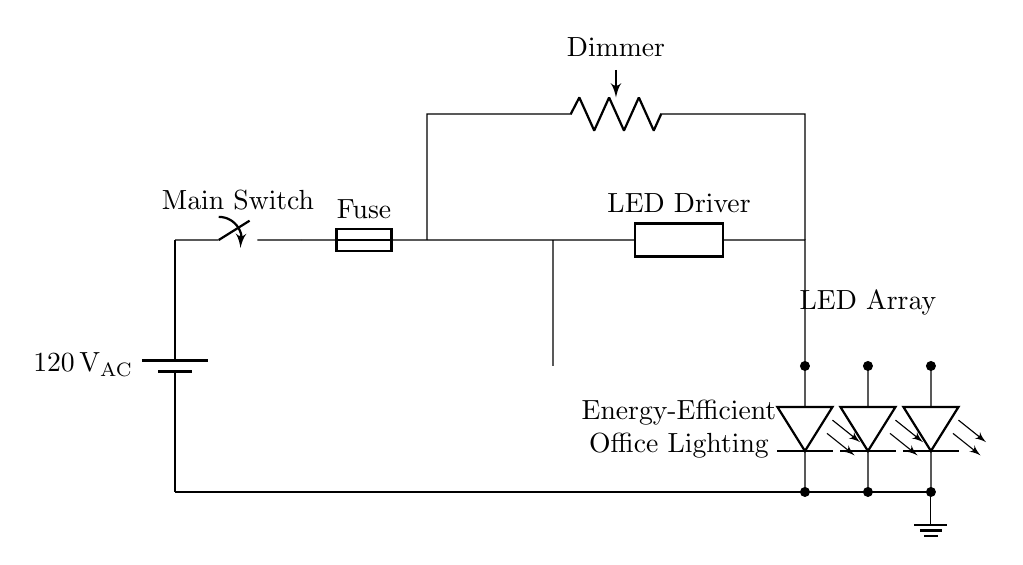What is the main power source used in this circuit? The circuit uses a battery symbol to represent the main power source, which is labeled as 120 volts AC. Therefore, the main power source is AC voltage.
Answer: 120 volts AC What component is used to control the brightness of the LED lights? The dimmer is a potentiometer, which is connected in series with the LED driver, allowing the user to adjust the brightness of the LED lights.
Answer: Dimmer How many LED arrays are present in the circuit? The circuit shows three LED arrays connected in parallel, as indicated by three separate LED symbols.
Answer: Three What is the purpose of the fuse in this circuit? The fuse is included to protect the circuit from overload or short circuits by breaking the circuit if the current exceeds a certain level, thus ensuring safety.
Answer: Protection What type of lighting does this circuit represent? The circuit is specifically designed for energy-efficient office lighting, as identified in the labels present in the circuit diagram.
Answer: Energy-efficient office lighting What is the position of the dimmer in the circuit diagram? The dimmer is positioned above the LED driver and is connected in a manner that allows it to receive power before distributing it to the LED arrays, which is critical for adjusting brightness.
Answer: Above the LED driver 